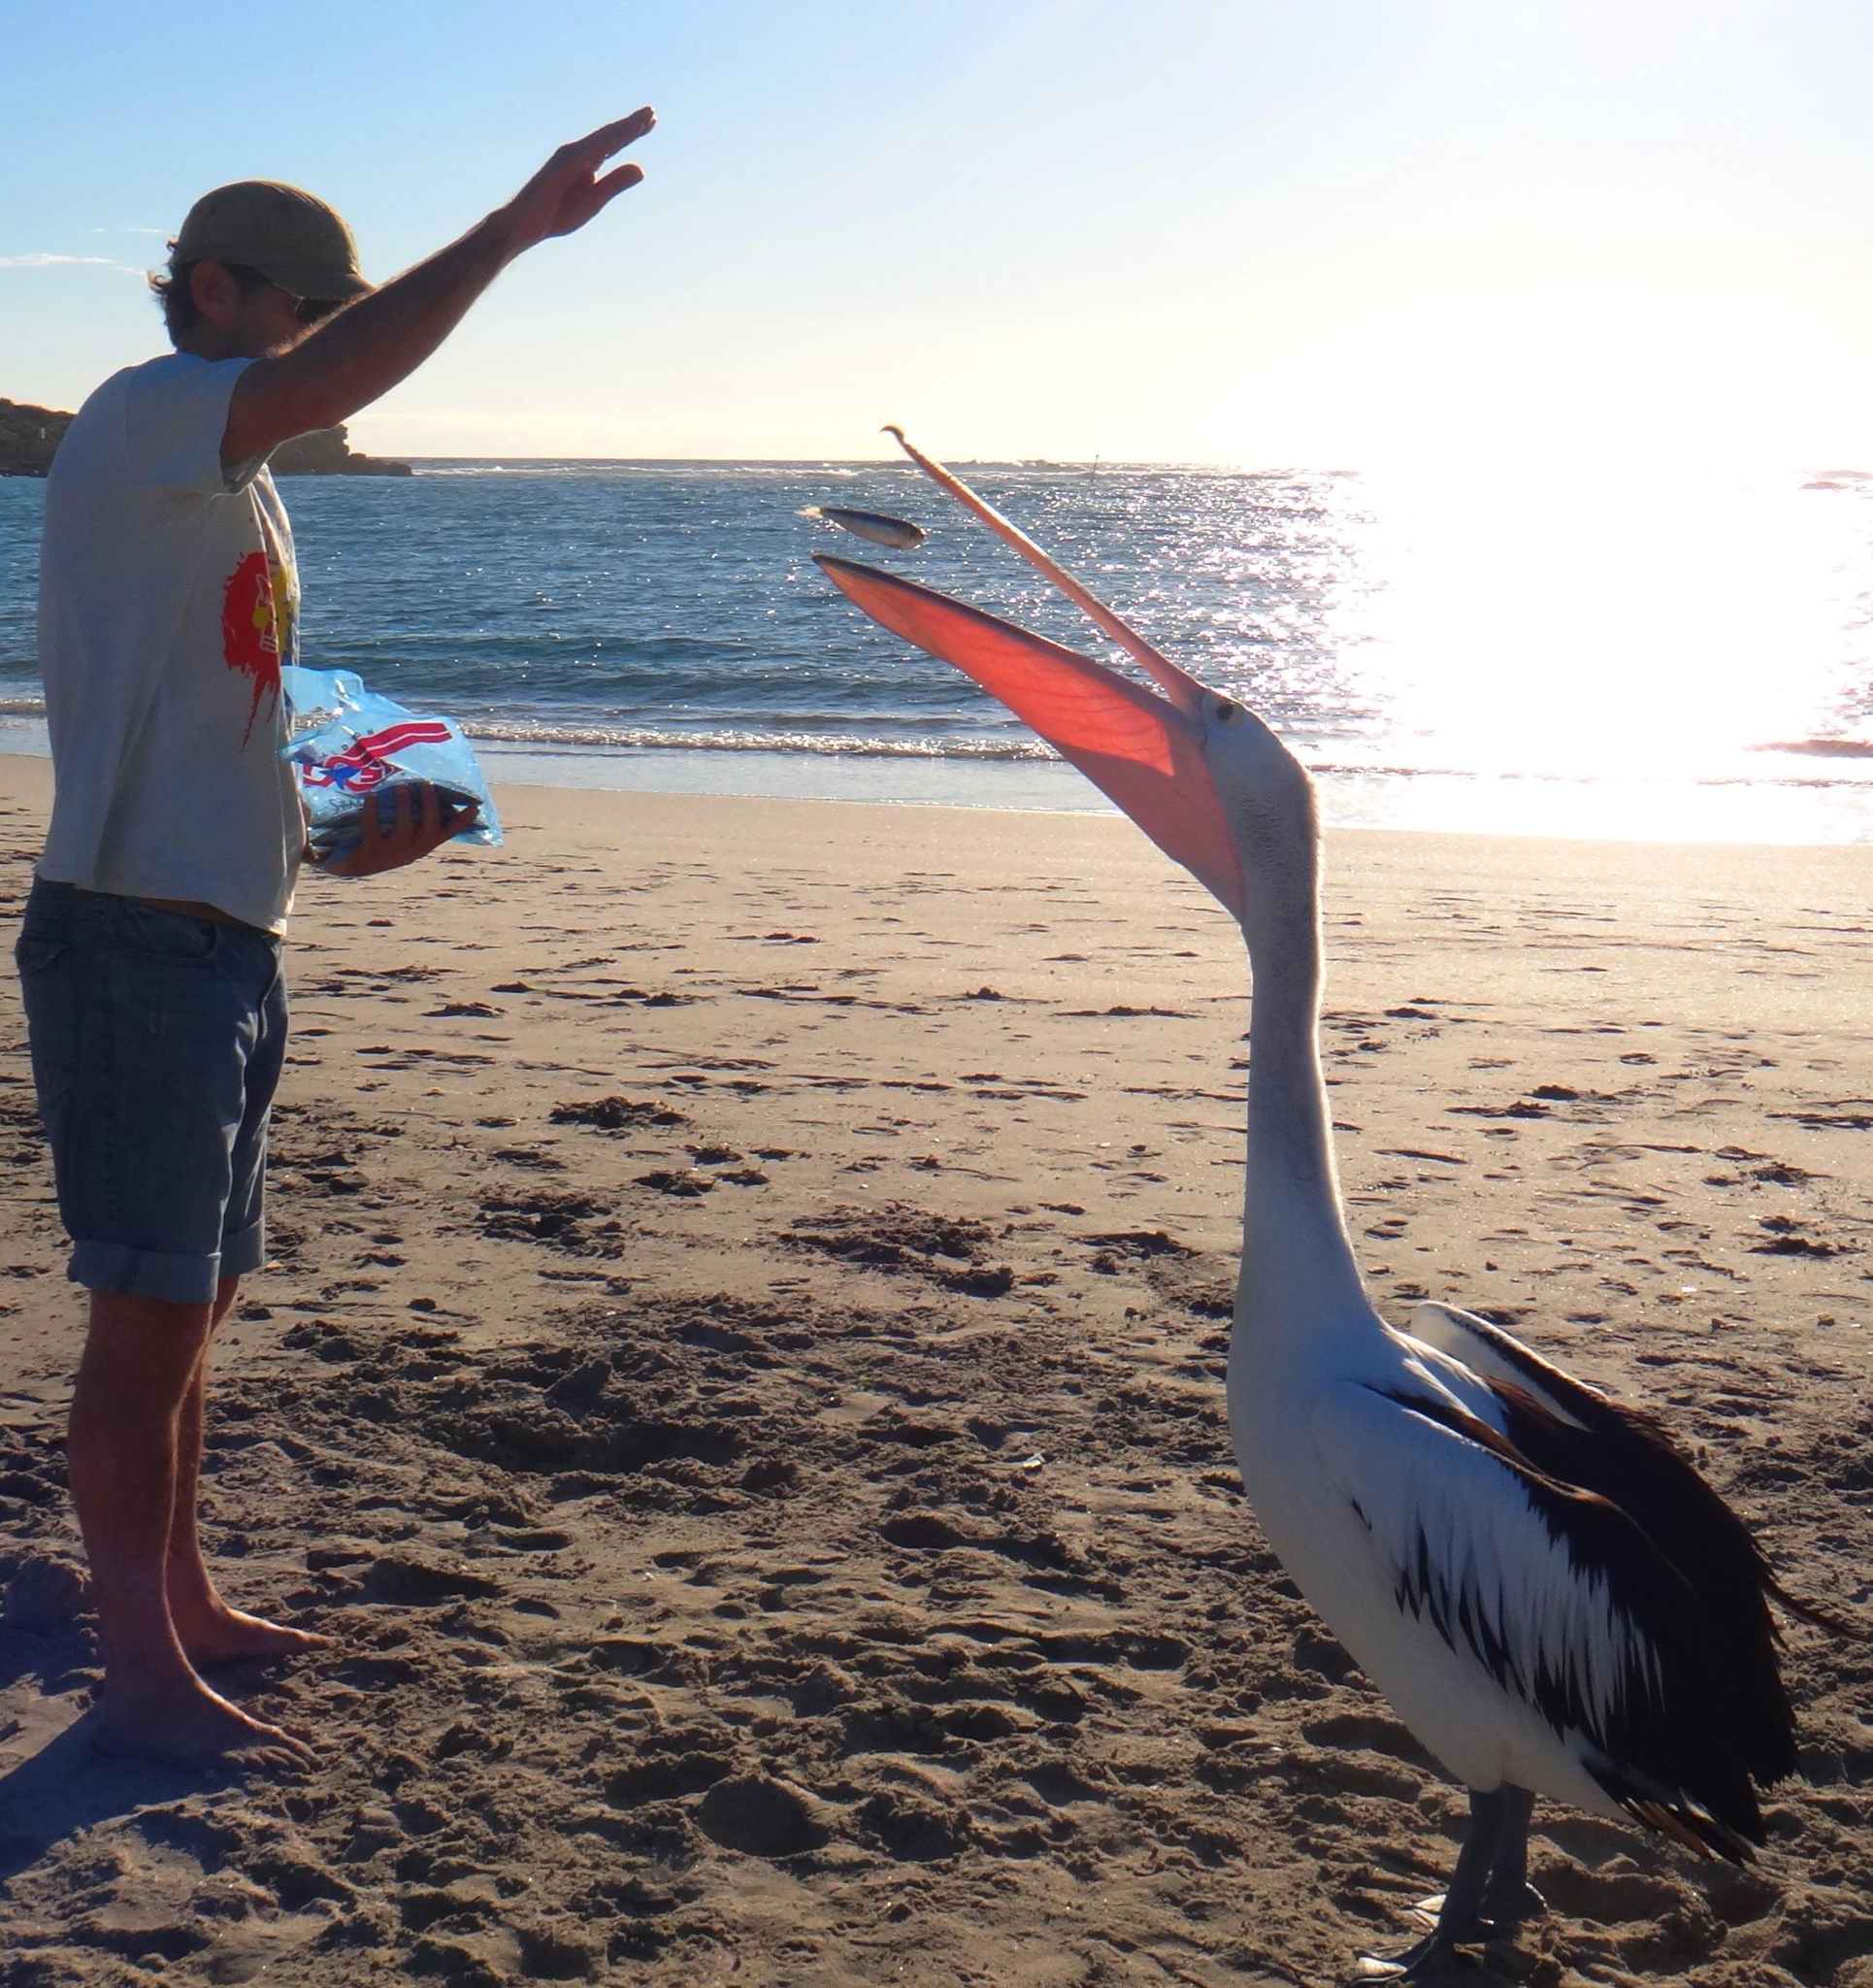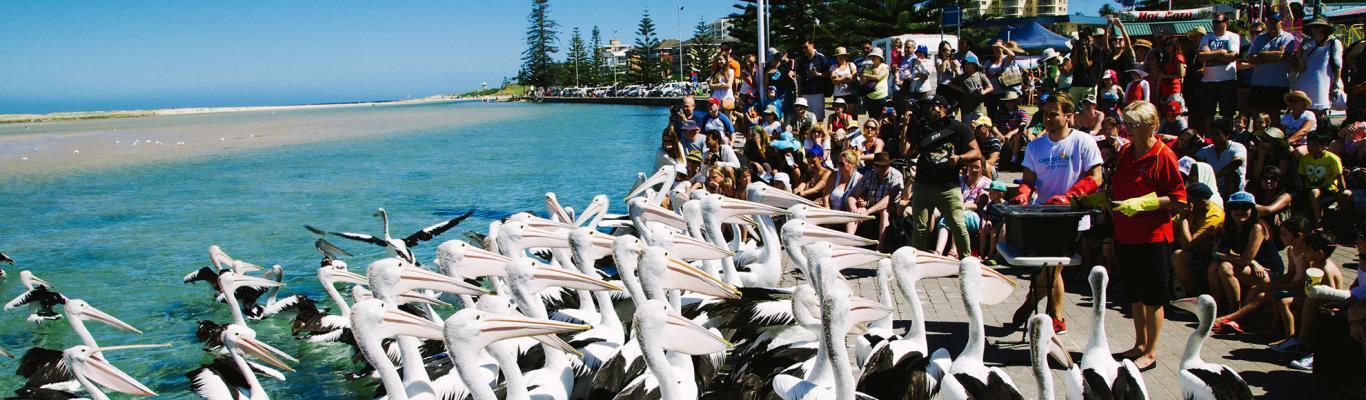The first image is the image on the left, the second image is the image on the right. Assess this claim about the two images: "There is one human interacting with at least one bird in the left image.". Correct or not? Answer yes or no. Yes. The first image is the image on the left, the second image is the image on the right. Analyze the images presented: Is the assertion "Each image shows a single pelican floating on water, and at least one image shows a fish in the bird's bill." valid? Answer yes or no. No. 